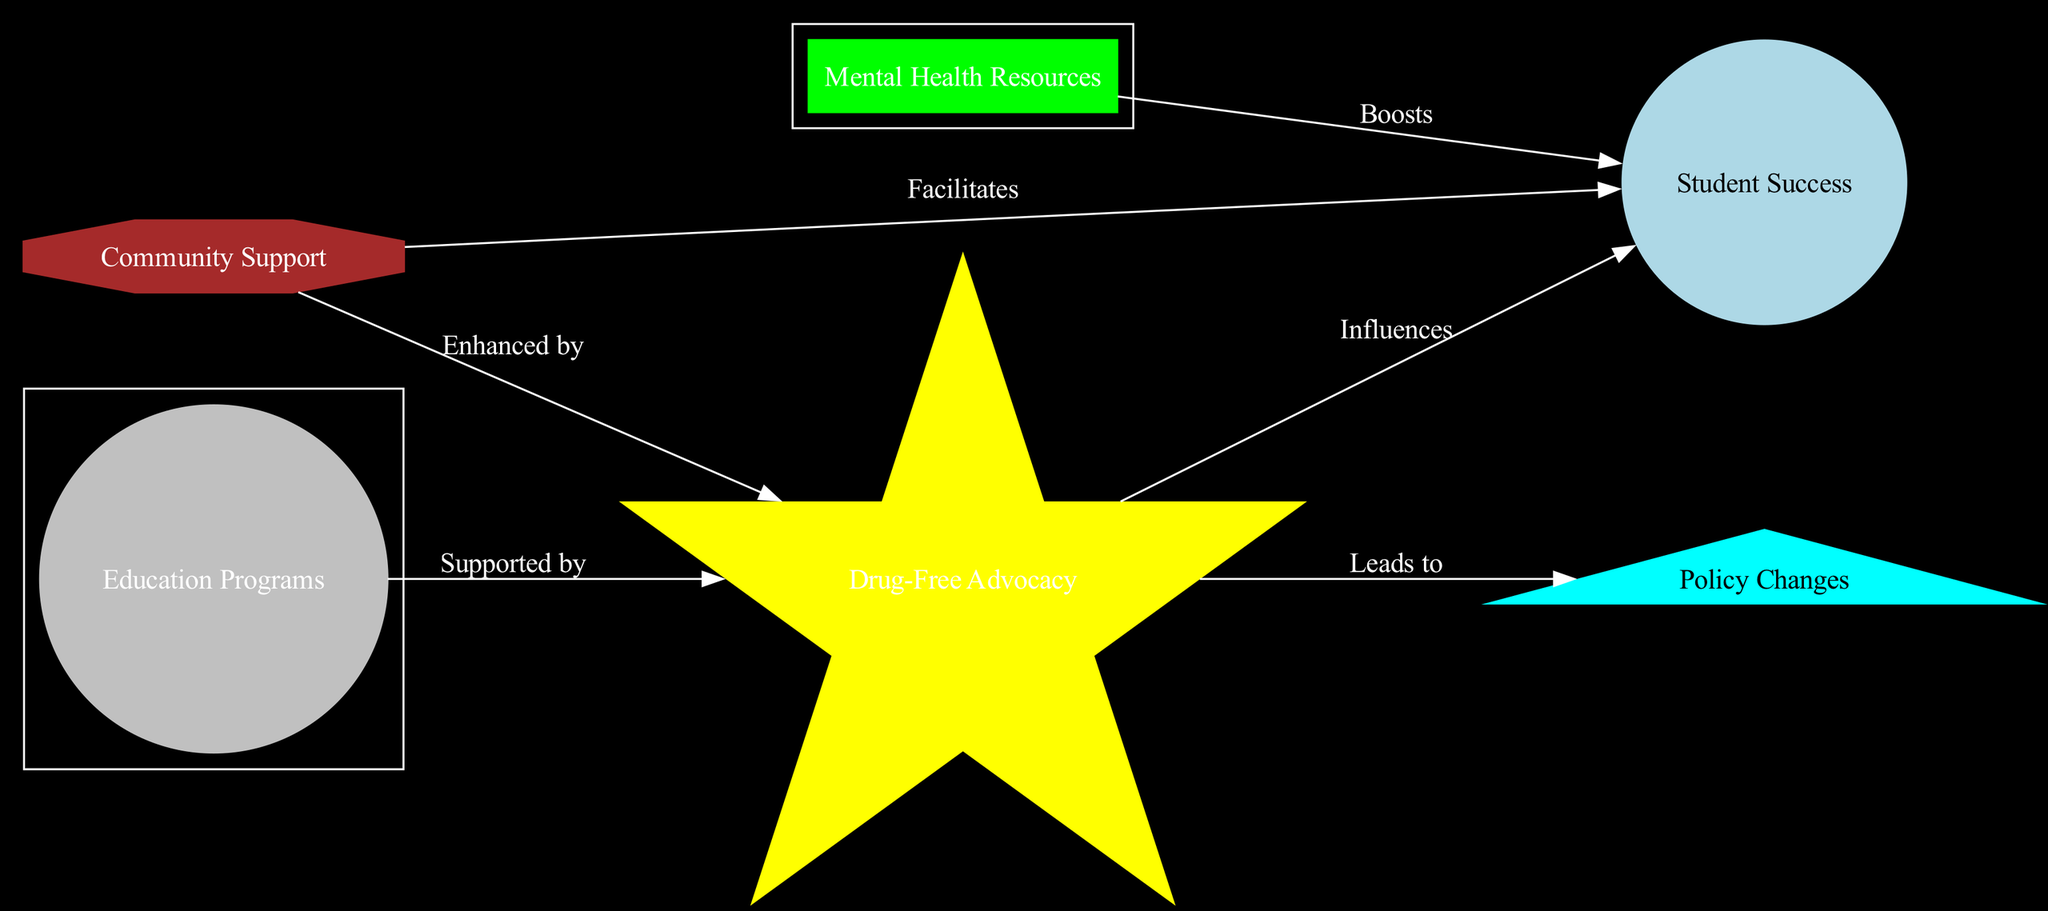What are the types of nodes in the diagram? The diagram includes star, planet, moon, asteroid, comet, and satellite as node types, which represent different roles in the context of drug-free advocacy and student success.
Answer: star, planet, moon, asteroid, comet, satellite Which node represents Drug-Free Advocacy? By examining the node labels in the diagram, Drug-Free Advocacy is identified as the node labeled "Drug-Free Advocacy."
Answer: Drug-Free Advocacy How many edges are in the diagram? The diagram contains a total of six edges connecting the nodes, as indicated by the edges listed in the data.
Answer: 6 What does the Mental Health Resources node boost? The edge from Mental Health Resources to Student Success shows that it boosts the success of students.
Answer: Student Success Which element supports Drug-Free Advocacy? The diagram indicates that Education Programs support Drug-Free Advocacy by referring to the directed edge labeled "Supported by."
Answer: Education Programs What is the relationship between Community Support and Student Success? The edge labeled "Facilitates" indicates a supportive relationship where Community Support facilitates Student Success.
Answer: Facilitates What is the role of the Education Programs node? The Education Programs node is depicted as a moon, indicating that it plays a supportive role to Drug-Free Advocacy and is a part of the broader context of Student Success.
Answer: Supported by Drug-Free Advocacy Which node leads to Policy Changes? The edge labeled "Leads to" indicates that Drug-Free Advocacy leads to Policy Changes.
Answer: Drug-Free Advocacy Which element enhances Drug-Free Advocacy? Community Support enhances Drug-Free Advocacy according to the directed edge labeled "Enhanced by."
Answer: Community Support 